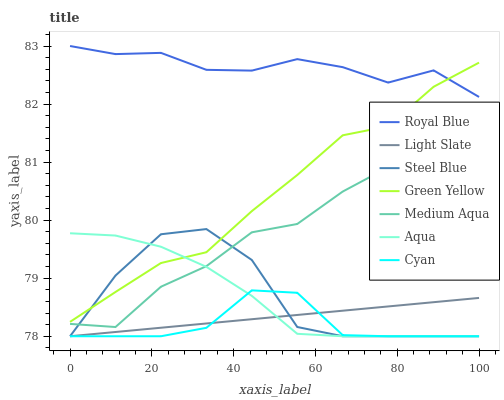Does Cyan have the minimum area under the curve?
Answer yes or no. Yes. Does Royal Blue have the maximum area under the curve?
Answer yes or no. Yes. Does Aqua have the minimum area under the curve?
Answer yes or no. No. Does Aqua have the maximum area under the curve?
Answer yes or no. No. Is Light Slate the smoothest?
Answer yes or no. Yes. Is Steel Blue the roughest?
Answer yes or no. Yes. Is Aqua the smoothest?
Answer yes or no. No. Is Aqua the roughest?
Answer yes or no. No. Does Light Slate have the lowest value?
Answer yes or no. Yes. Does Royal Blue have the lowest value?
Answer yes or no. No. Does Royal Blue have the highest value?
Answer yes or no. Yes. Does Aqua have the highest value?
Answer yes or no. No. Is Aqua less than Royal Blue?
Answer yes or no. Yes. Is Royal Blue greater than Cyan?
Answer yes or no. Yes. Does Cyan intersect Steel Blue?
Answer yes or no. Yes. Is Cyan less than Steel Blue?
Answer yes or no. No. Is Cyan greater than Steel Blue?
Answer yes or no. No. Does Aqua intersect Royal Blue?
Answer yes or no. No. 